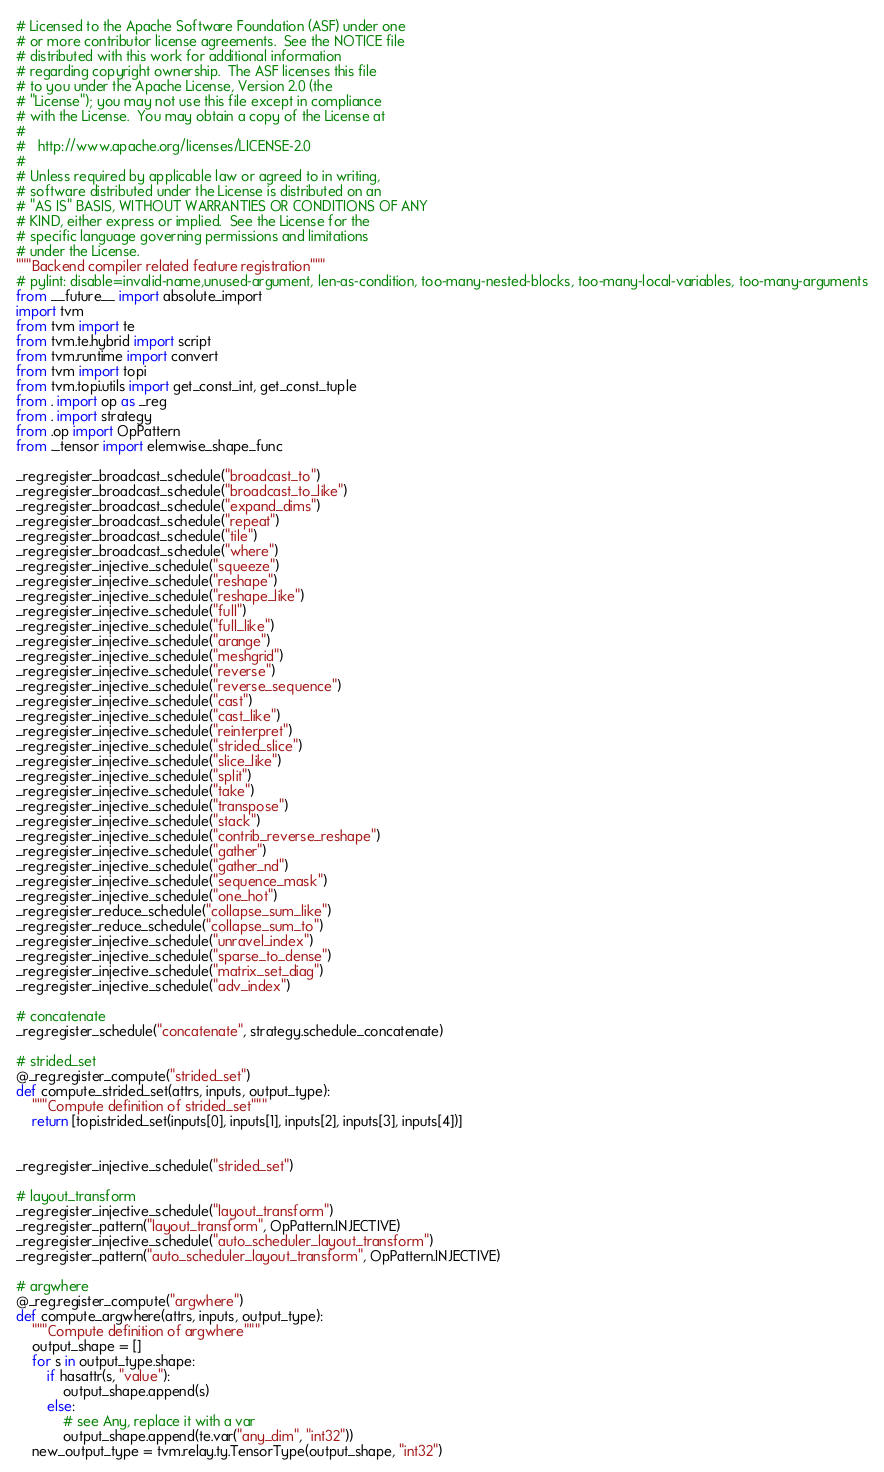Convert code to text. <code><loc_0><loc_0><loc_500><loc_500><_Python_># Licensed to the Apache Software Foundation (ASF) under one
# or more contributor license agreements.  See the NOTICE file
# distributed with this work for additional information
# regarding copyright ownership.  The ASF licenses this file
# to you under the Apache License, Version 2.0 (the
# "License"); you may not use this file except in compliance
# with the License.  You may obtain a copy of the License at
#
#   http://www.apache.org/licenses/LICENSE-2.0
#
# Unless required by applicable law or agreed to in writing,
# software distributed under the License is distributed on an
# "AS IS" BASIS, WITHOUT WARRANTIES OR CONDITIONS OF ANY
# KIND, either express or implied.  See the License for the
# specific language governing permissions and limitations
# under the License.
"""Backend compiler related feature registration"""
# pylint: disable=invalid-name,unused-argument, len-as-condition, too-many-nested-blocks, too-many-local-variables, too-many-arguments
from __future__ import absolute_import
import tvm
from tvm import te
from tvm.te.hybrid import script
from tvm.runtime import convert
from tvm import topi
from tvm.topi.utils import get_const_int, get_const_tuple
from . import op as _reg
from . import strategy
from .op import OpPattern
from ._tensor import elemwise_shape_func

_reg.register_broadcast_schedule("broadcast_to")
_reg.register_broadcast_schedule("broadcast_to_like")
_reg.register_broadcast_schedule("expand_dims")
_reg.register_broadcast_schedule("repeat")
_reg.register_broadcast_schedule("tile")
_reg.register_broadcast_schedule("where")
_reg.register_injective_schedule("squeeze")
_reg.register_injective_schedule("reshape")
_reg.register_injective_schedule("reshape_like")
_reg.register_injective_schedule("full")
_reg.register_injective_schedule("full_like")
_reg.register_injective_schedule("arange")
_reg.register_injective_schedule("meshgrid")
_reg.register_injective_schedule("reverse")
_reg.register_injective_schedule("reverse_sequence")
_reg.register_injective_schedule("cast")
_reg.register_injective_schedule("cast_like")
_reg.register_injective_schedule("reinterpret")
_reg.register_injective_schedule("strided_slice")
_reg.register_injective_schedule("slice_like")
_reg.register_injective_schedule("split")
_reg.register_injective_schedule("take")
_reg.register_injective_schedule("transpose")
_reg.register_injective_schedule("stack")
_reg.register_injective_schedule("contrib_reverse_reshape")
_reg.register_injective_schedule("gather")
_reg.register_injective_schedule("gather_nd")
_reg.register_injective_schedule("sequence_mask")
_reg.register_injective_schedule("one_hot")
_reg.register_reduce_schedule("collapse_sum_like")
_reg.register_reduce_schedule("collapse_sum_to")
_reg.register_injective_schedule("unravel_index")
_reg.register_injective_schedule("sparse_to_dense")
_reg.register_injective_schedule("matrix_set_diag")
_reg.register_injective_schedule("adv_index")

# concatenate
_reg.register_schedule("concatenate", strategy.schedule_concatenate)

# strided_set
@_reg.register_compute("strided_set")
def compute_strided_set(attrs, inputs, output_type):
    """Compute definition of strided_set"""
    return [topi.strided_set(inputs[0], inputs[1], inputs[2], inputs[3], inputs[4])]


_reg.register_injective_schedule("strided_set")

# layout_transform
_reg.register_injective_schedule("layout_transform")
_reg.register_pattern("layout_transform", OpPattern.INJECTIVE)
_reg.register_injective_schedule("auto_scheduler_layout_transform")
_reg.register_pattern("auto_scheduler_layout_transform", OpPattern.INJECTIVE)

# argwhere
@_reg.register_compute("argwhere")
def compute_argwhere(attrs, inputs, output_type):
    """Compute definition of argwhere"""
    output_shape = []
    for s in output_type.shape:
        if hasattr(s, "value"):
            output_shape.append(s)
        else:
            # see Any, replace it with a var
            output_shape.append(te.var("any_dim", "int32"))
    new_output_type = tvm.relay.ty.TensorType(output_shape, "int32")</code> 